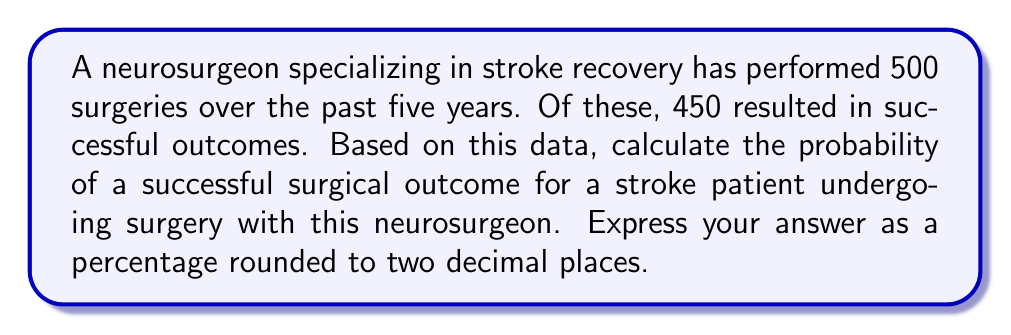Can you answer this question? To calculate the probability of a successful surgical outcome, we need to use the concept of relative frequency as an estimate of probability. Here's how we can solve this step-by-step:

1. Identify the total number of surgeries:
   Total surgeries = 500

2. Identify the number of successful surgeries:
   Successful surgeries = 450

3. Calculate the probability using the formula:
   $$P(\text{success}) = \frac{\text{Number of successful outcomes}}{\text{Total number of outcomes}}$$

4. Plug in the values:
   $$P(\text{success}) = \frac{450}{500}$$

5. Perform the division:
   $$P(\text{success}) = 0.9$$

6. Convert to a percentage:
   $$0.9 \times 100\% = 90\%$$

7. Round to two decimal places:
   90.00%

Therefore, based on the given data, the probability of a successful surgical outcome for a stroke patient with this neurosurgeon is 90.00%.
Answer: 90.00% 